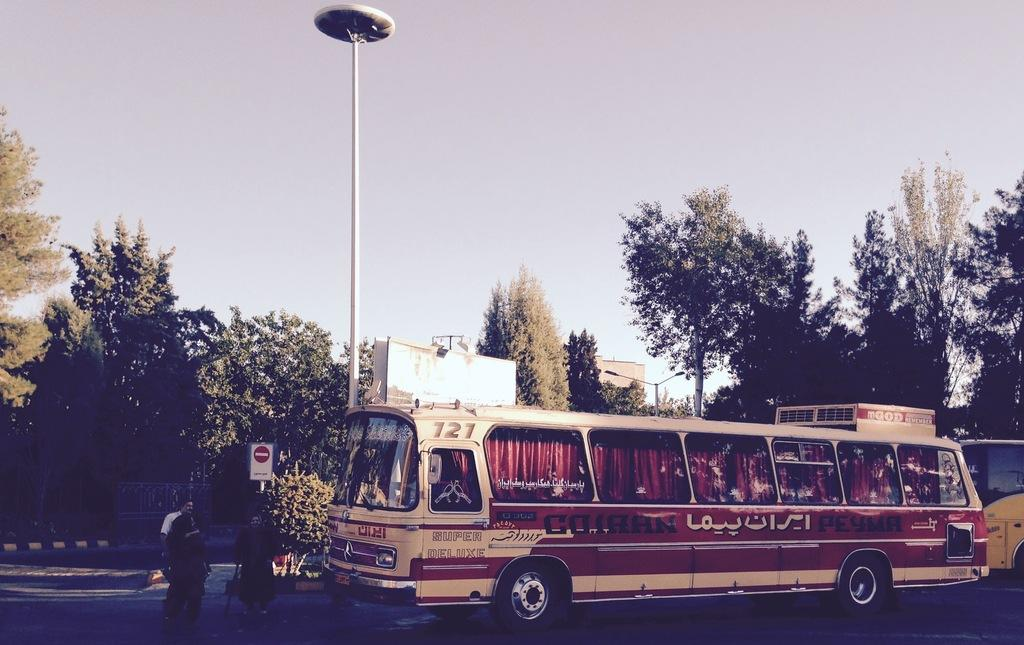<image>
Summarize the visual content of the image. A red and white bus with the number 121. 